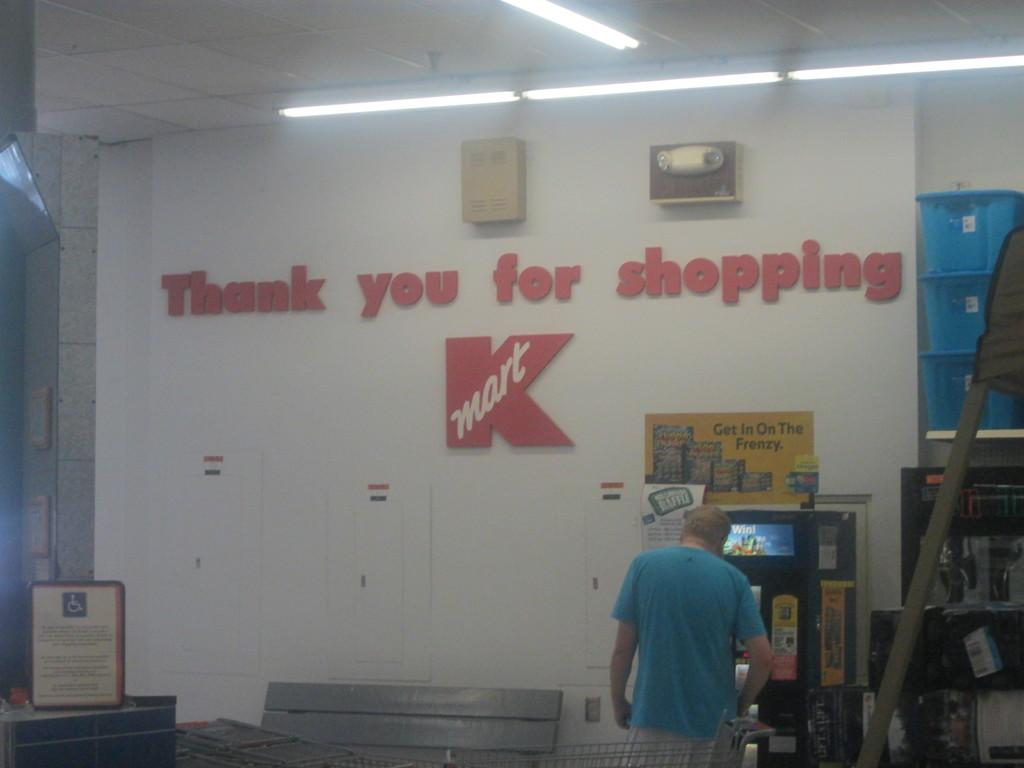What is the main subject of the image? There is a person in the image. What can be seen in the background of the image? There is a cart, boards, a vending machine, baskets, lights, a ceiling, and a wall in the image. Are there any decorative elements in the image? Yes, there are posters in the image. What other objects can be seen in the image? There are other objects in the image, but their specific details are not mentioned in the provided facts. What type of furniture is being distributed in the image? There is no furniture or distribution process depicted in the image. 